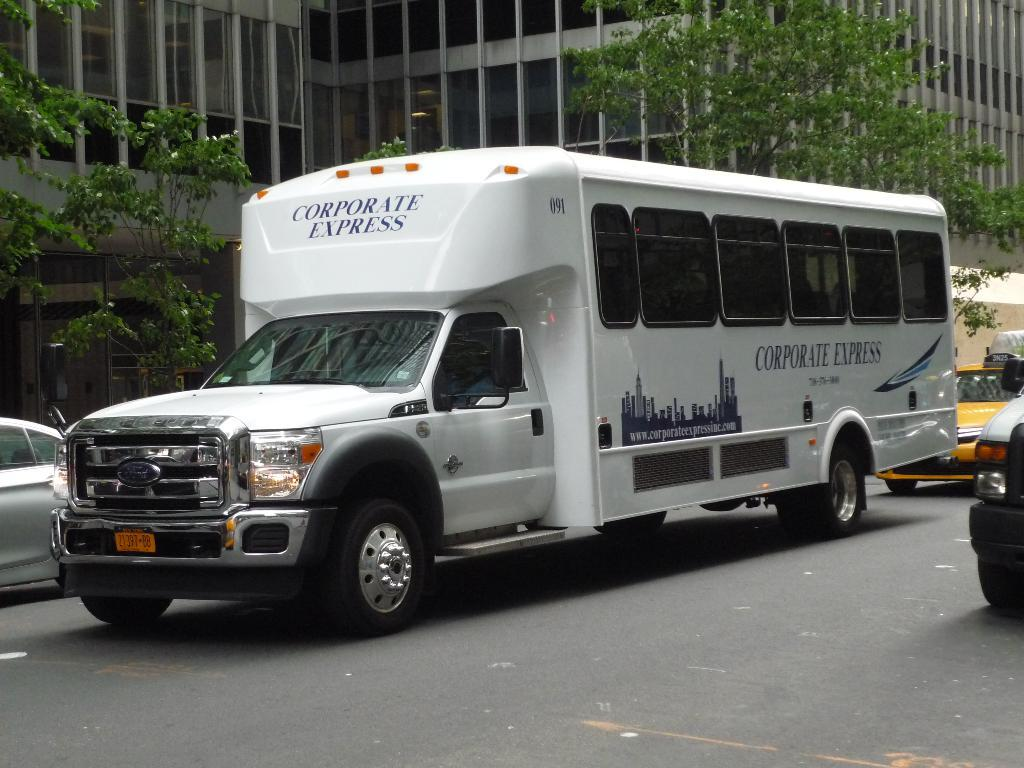What is happening on the road in the image? There are vehicles on the road in the image. What can be seen in the background of the image? There are trees, at least one building, and some unspecified objects in the background of the image. What type of bottle is being used to catch the zephyr in the image? There is no bottle or zephyr present in the image. 